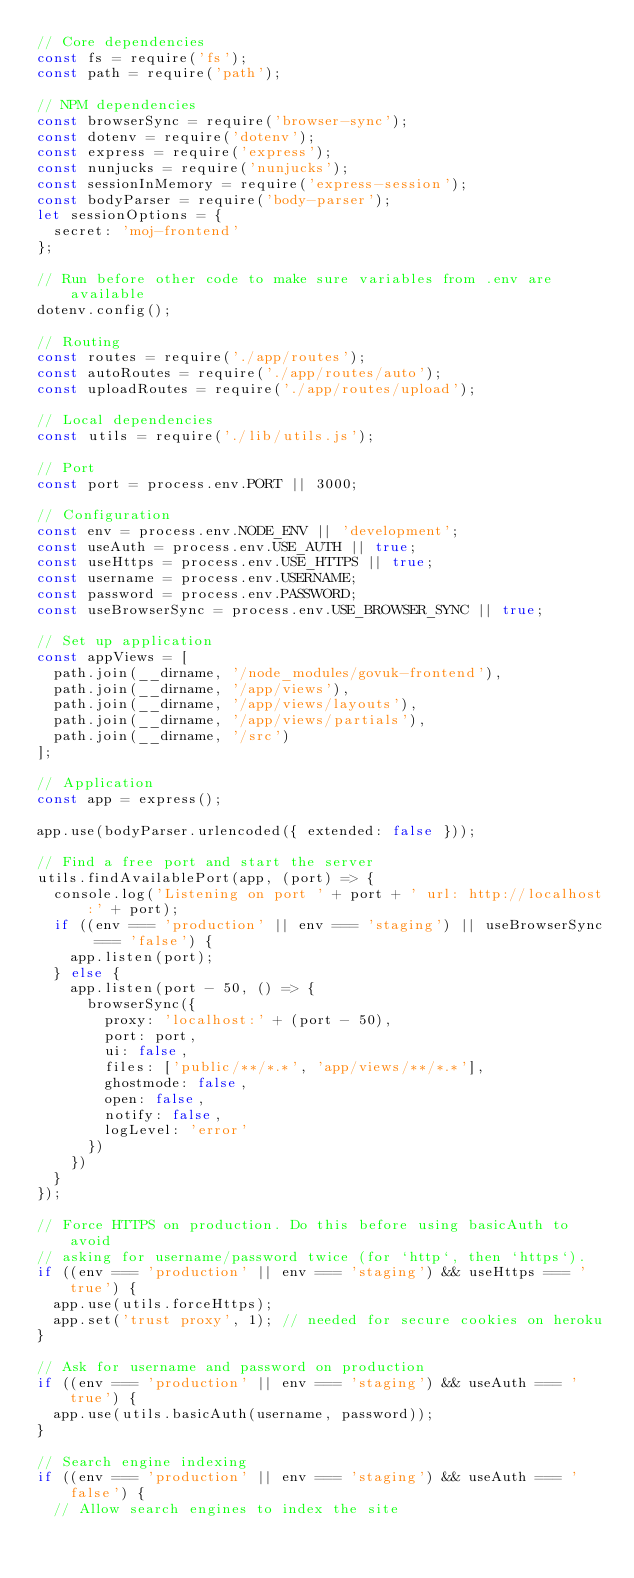Convert code to text. <code><loc_0><loc_0><loc_500><loc_500><_JavaScript_>// Core dependencies
const fs = require('fs');
const path = require('path');

// NPM dependencies
const browserSync = require('browser-sync');
const dotenv = require('dotenv');
const express = require('express');
const nunjucks = require('nunjucks');
const sessionInMemory = require('express-session');
const bodyParser = require('body-parser');
let sessionOptions = {
  secret: 'moj-frontend'
};

// Run before other code to make sure variables from .env are available
dotenv.config();

// Routing
const routes = require('./app/routes');
const autoRoutes = require('./app/routes/auto');
const uploadRoutes = require('./app/routes/upload');

// Local dependencies
const utils = require('./lib/utils.js');

// Port
const port = process.env.PORT || 3000;

// Configuration
const env = process.env.NODE_ENV || 'development';
const useAuth = process.env.USE_AUTH || true;
const useHttps = process.env.USE_HTTPS || true;
const username = process.env.USERNAME;
const password = process.env.PASSWORD;
const useBrowserSync = process.env.USE_BROWSER_SYNC || true;

// Set up application
const appViews = [
  path.join(__dirname, '/node_modules/govuk-frontend'),
  path.join(__dirname, '/app/views'),
  path.join(__dirname, '/app/views/layouts'),
  path.join(__dirname, '/app/views/partials'),
  path.join(__dirname, '/src')
];

// Application
const app = express();

app.use(bodyParser.urlencoded({ extended: false }));

// Find a free port and start the server
utils.findAvailablePort(app, (port) => {
  console.log('Listening on port ' + port + ' url: http://localhost:' + port);
  if ((env === 'production' || env === 'staging') || useBrowserSync === 'false') {
    app.listen(port);
  } else {
    app.listen(port - 50, () => {
      browserSync({
        proxy: 'localhost:' + (port - 50),
        port: port,
        ui: false,
        files: ['public/**/*.*', 'app/views/**/*.*'],
        ghostmode: false,
        open: false,
        notify: false,
        logLevel: 'error'
      })
    })
  }
});

// Force HTTPS on production. Do this before using basicAuth to avoid
// asking for username/password twice (for `http`, then `https`).
if ((env === 'production' || env === 'staging') && useHttps === 'true') {
  app.use(utils.forceHttps);
  app.set('trust proxy', 1); // needed for secure cookies on heroku
}

// Ask for username and password on production
if ((env === 'production' || env === 'staging') && useAuth === 'true') {
  app.use(utils.basicAuth(username, password));
}

// Search engine indexing
if ((env === 'production' || env === 'staging') && useAuth === 'false') {
  // Allow search engines to index the site</code> 